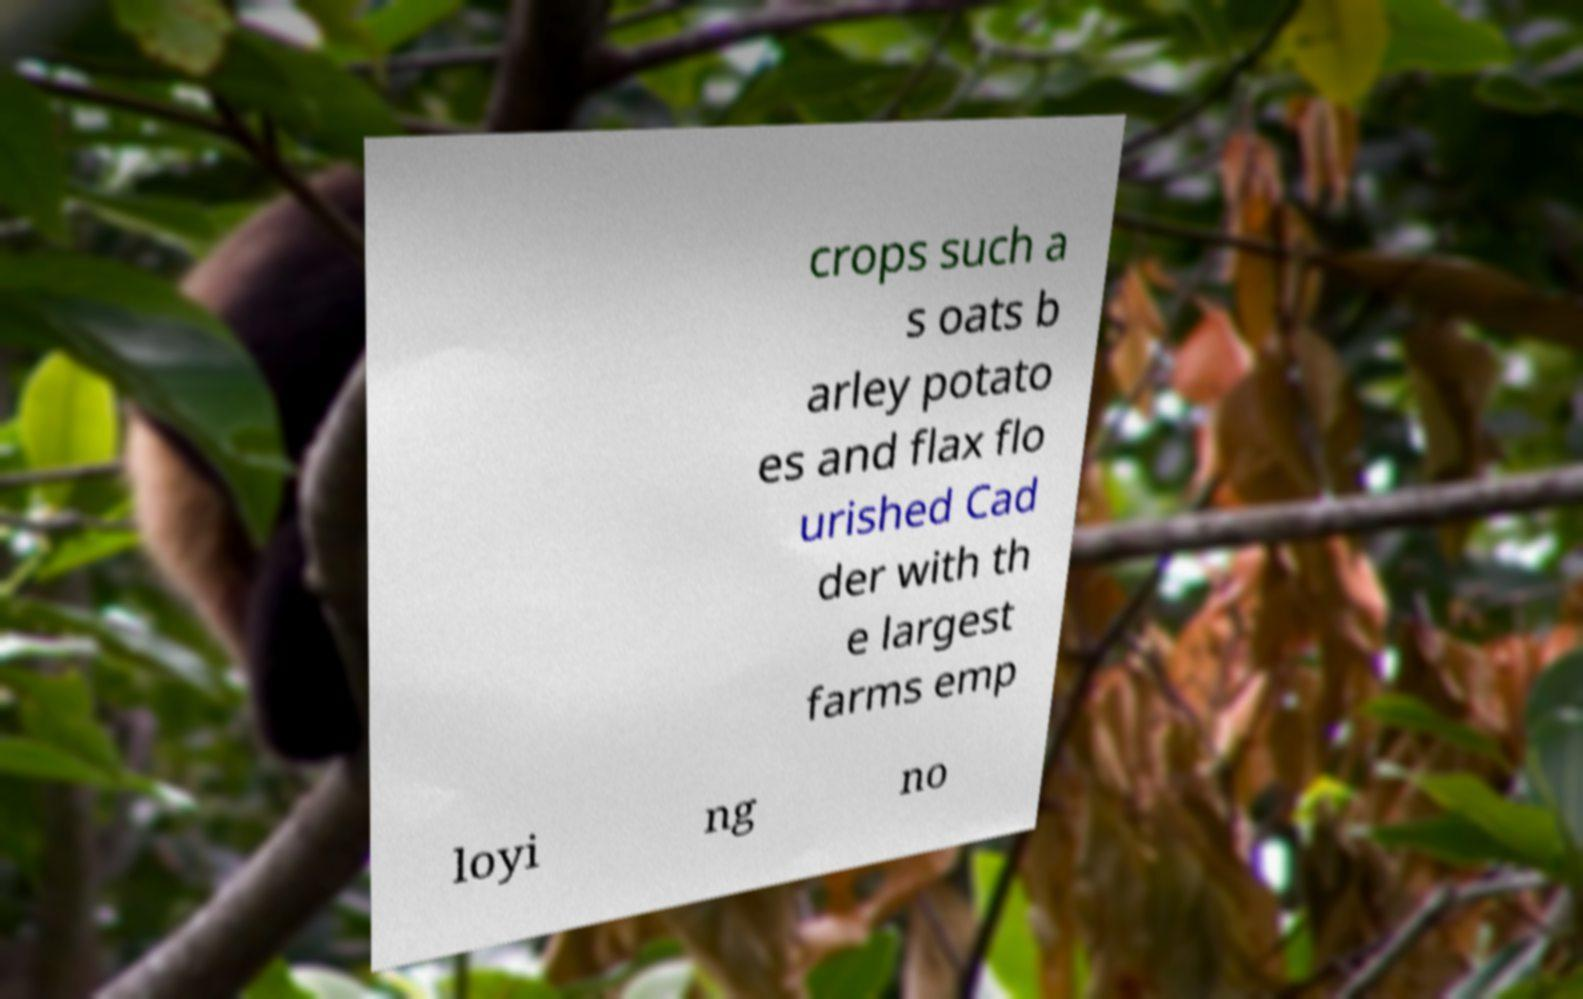Could you assist in decoding the text presented in this image and type it out clearly? crops such a s oats b arley potato es and flax flo urished Cad der with th e largest farms emp loyi ng no 